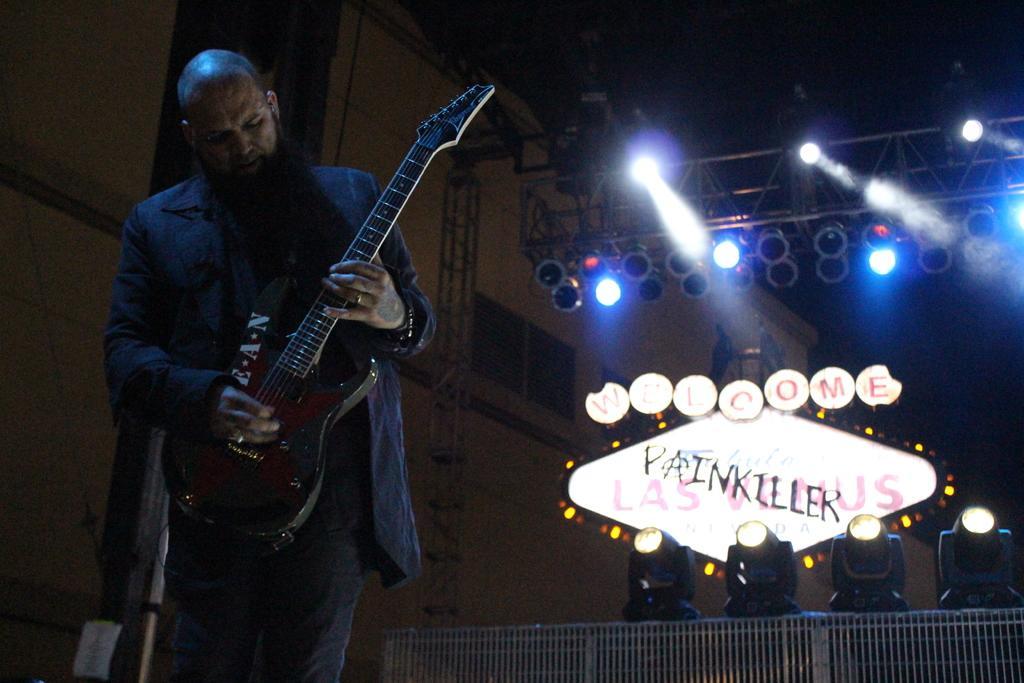How would you summarize this image in a sentence or two? He is standing and his holding a guitar at the same time his playing a guitar. We can see in the background there is a lights and poster. 